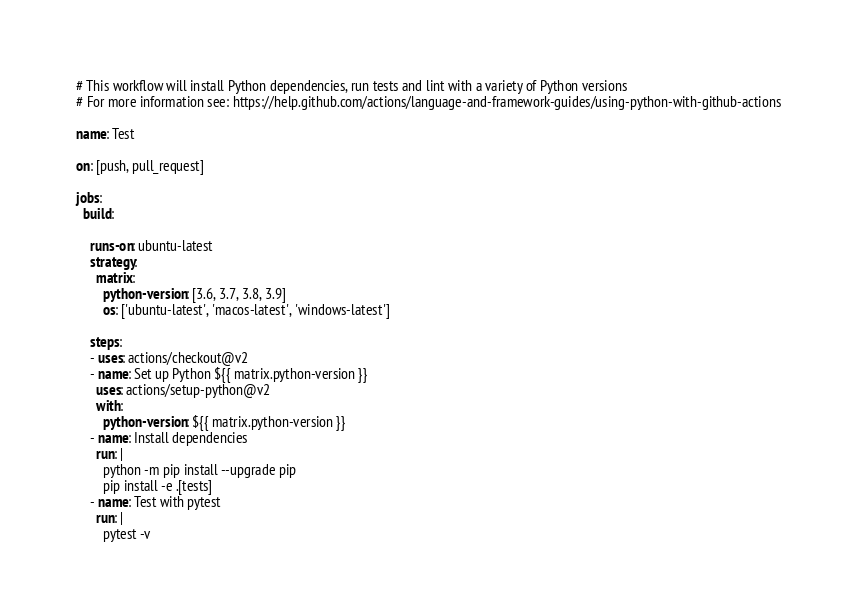<code> <loc_0><loc_0><loc_500><loc_500><_YAML_># This workflow will install Python dependencies, run tests and lint with a variety of Python versions
# For more information see: https://help.github.com/actions/language-and-framework-guides/using-python-with-github-actions

name: Test

on: [push, pull_request]

jobs:
  build:

    runs-on: ubuntu-latest
    strategy:
      matrix:
        python-version: [3.6, 3.7, 3.8, 3.9]
        os: ['ubuntu-latest', 'macos-latest', 'windows-latest']

    steps:
    - uses: actions/checkout@v2
    - name: Set up Python ${{ matrix.python-version }}
      uses: actions/setup-python@v2
      with:
        python-version: ${{ matrix.python-version }}
    - name: Install dependencies
      run: |
        python -m pip install --upgrade pip
        pip install -e .[tests]
    - name: Test with pytest
      run: |
        pytest -v</code> 